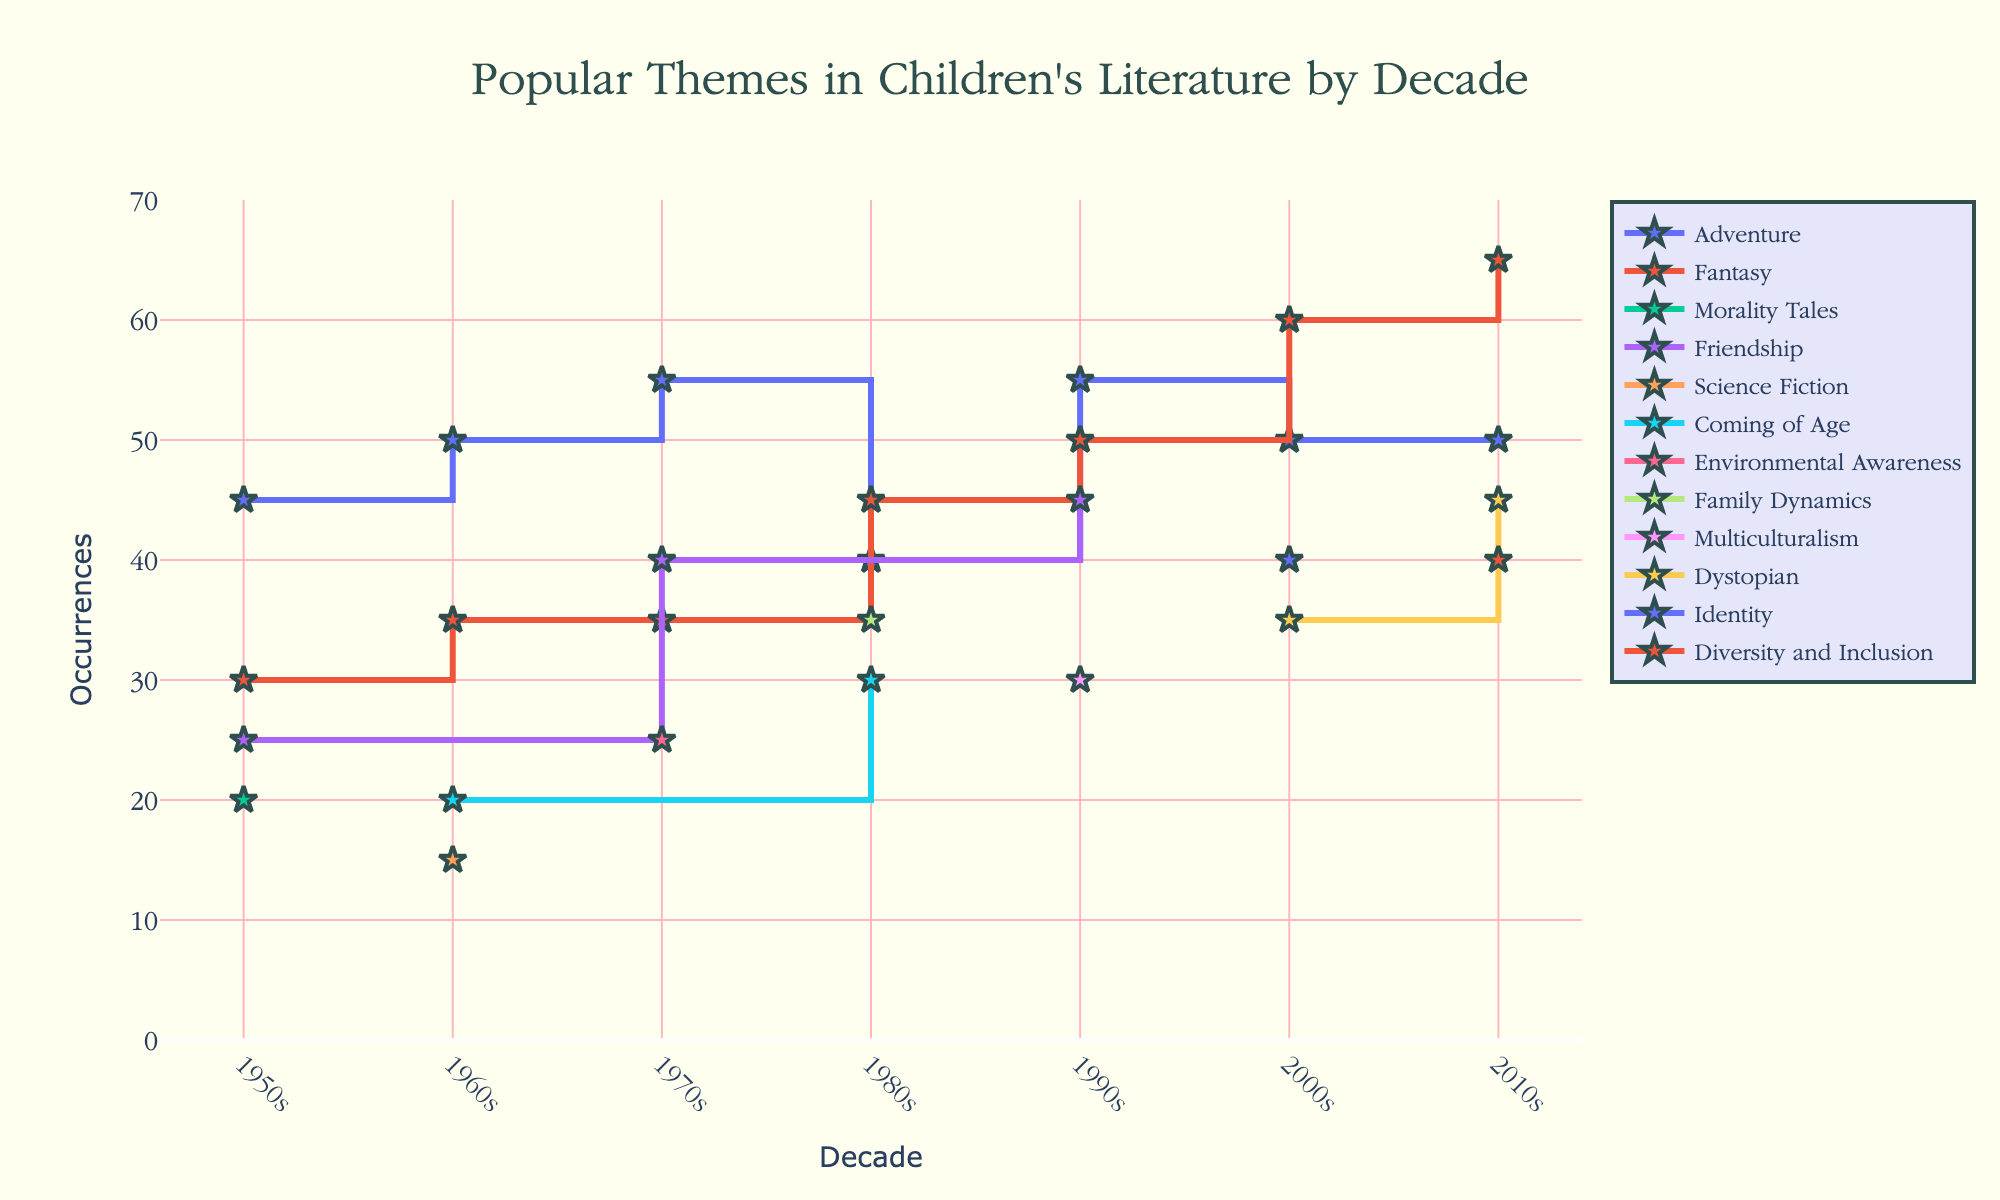What's the title of the plot? The title is displayed at the top of the plot.
Answer: Popular Themes in Children's Literature by Decade Which theme has the highest count in the 2010s? By looking at the y-axis values for the 2010s, the theme with the highest occurrences is Fantasy.
Answer: Fantasy What was the most popular theme in the 1950s? In the 1950s, the data shows that Adventure had the highest occurrence (45) compared to other themes.
Answer: Adventure Which decade has the highest number of occurrences for Fantasy themes? By comparing the occurrences of Fantasy themes across decades, the highest is in the 2010s with 65 occurrences.
Answer: 2010s How many themes have more than 50 occurrences in the 2000s? Observing the y-axis values for the 2000s shows Fantasy (60 occurrences) as the only theme with more than 50 occurrences.
Answer: 1 What's the difference in occurrences of Dystopian themes between the 2000s and 2010s? The occurrences in the 2000s are 35, and in the 2010s are 45. The difference is 45 - 35 = 10.
Answer: 10 Which theme shows a consistent increase in popularity from the 1960s to the 2010s? Fantasy consistently increases in occurrence from 35 in the 1960s to 65 in the 2010s.
Answer: Fantasy In which decade did Environmental Awareness themes first appear? Environmental Awareness themes appear first in the 1970s.
Answer: 1970s What is the total number of occurrences for Coming of Age themes across all decades? Adding the occurrences for Coming of Age themes: 1960s (20) + 1980s (30) = 50.
Answer: 50 Which theme had the least occurrence in the 1990s? Comparing all themes in the 1990s, Multiculturalism had the least with 30 occurrences.
Answer: Multiculturalism 